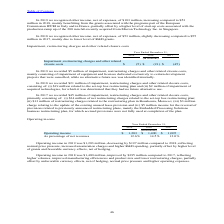According to Stmicroelectronics's financial document, In 2019, what constituted Impairment, restructuring charges and other related closure costs? mainly consisting of impairment of equipment and licenses dedicated exclusively to certain development projects that were cancelled, while no alternative future use was identified internally.. The document states: "ructuring charges and other related closure costs, mainly consisting of impairment of equipment and licenses dedicated exclusively to certain developm..." Also, In 2018, what constituted Impairment, restructuring charges and other related closure costs? (i) $19 million related to the set-top box restructuring plan and (ii) $2 million of impairment of acquired technologies, for which it was determined that they had no future alternative use.. The document states: "es and other related closure costs, consisting of: (i) $19 million related to the set-top box restructuring plan and (ii) $2 million of impairment of ..." Also, How much was the net restructuring charges related to the set-top box restructuring plan in 2017? According to the financial document, $34 million. The relevant text states: "elated closure costs, primarily consisting of: (i) $34 million of net restructuring charges related to the set-top box restructuring plan; (ii) $13 million of rest..." Also, can you calculate: What is the average Impairment, restructuring charges and other related closure costs? To answer this question, I need to perform calculations using the financial data. The calculation is: (5+21+45) / 3, which equals 23.67 (in millions). This is based on the information: "s and other related closure costs $ (5) $ (21) $ (45) charges and other related closure costs $ (5) $ (21) $ (45) s and other related closure costs $ (5) $ (21) $ (45)..." The key data points involved are: 21, 45, 5. Also, can you calculate: What is the increase/ (decrease) in Impairment, restructuring charges and other related closure costs from 2017 to 2019? Based on the calculation: 5-45, the result is -40 (in millions). This is based on the information: "s and other related closure costs $ (5) $ (21) $ (45) s and other related closure costs $ (5) $ (21) $ (45)..." The key data points involved are: 45, 5. Also, can you calculate: What is the increase/ (decrease) in Impairment, restructuring charges and other related closure costs from 2017 to 2018? Based on the calculation: 21-45, the result is -24 (in millions). This is based on the information: "s and other related closure costs $ (5) $ (21) $ (45) charges and other related closure costs $ (5) $ (21) $ (45)..." The key data points involved are: 21, 45. 